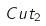Convert formula to latex. <formula><loc_0><loc_0><loc_500><loc_500>C u t _ { 2 }</formula> 